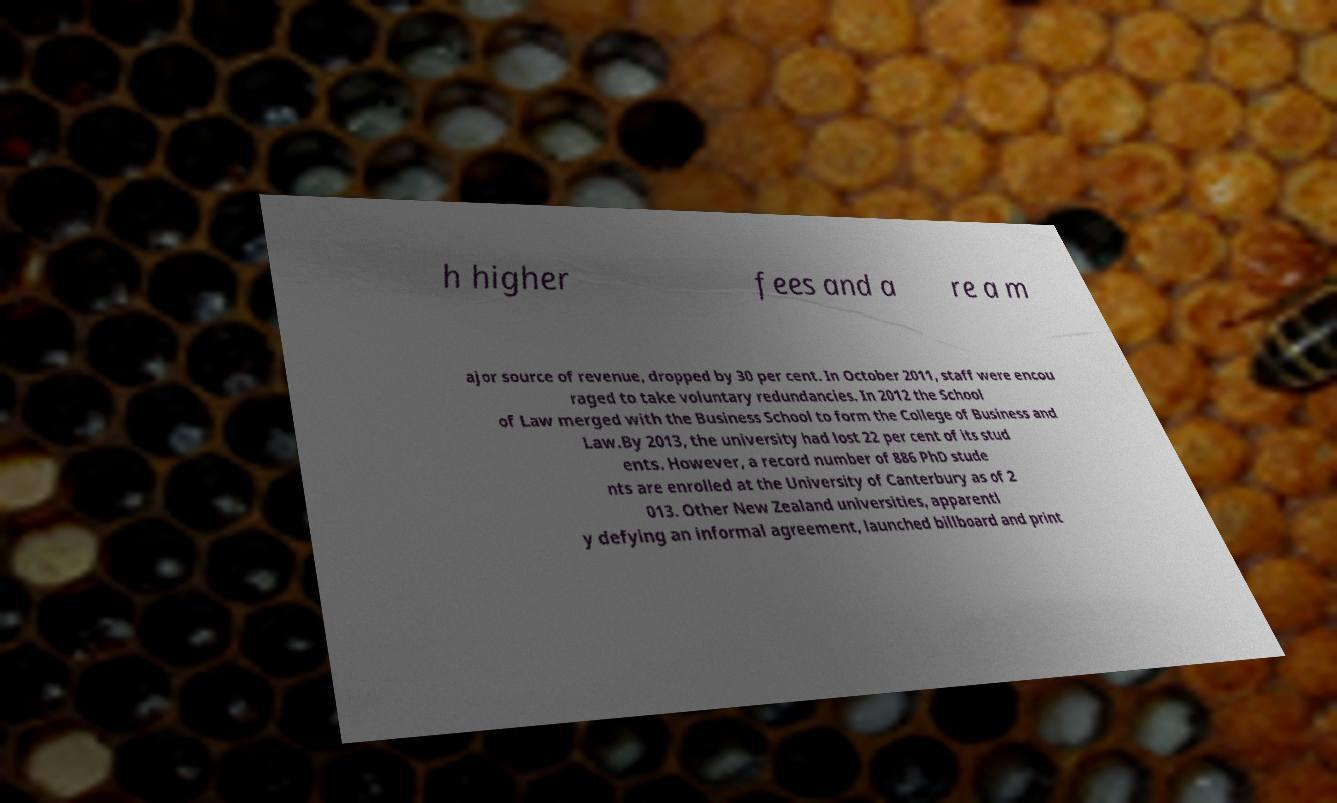Please read and relay the text visible in this image. What does it say? h higher fees and a re a m ajor source of revenue, dropped by 30 per cent. In October 2011, staff were encou raged to take voluntary redundancies. In 2012 the School of Law merged with the Business School to form the College of Business and Law.By 2013, the university had lost 22 per cent of its stud ents. However, a record number of 886 PhD stude nts are enrolled at the University of Canterbury as of 2 013. Other New Zealand universities, apparentl y defying an informal agreement, launched billboard and print 